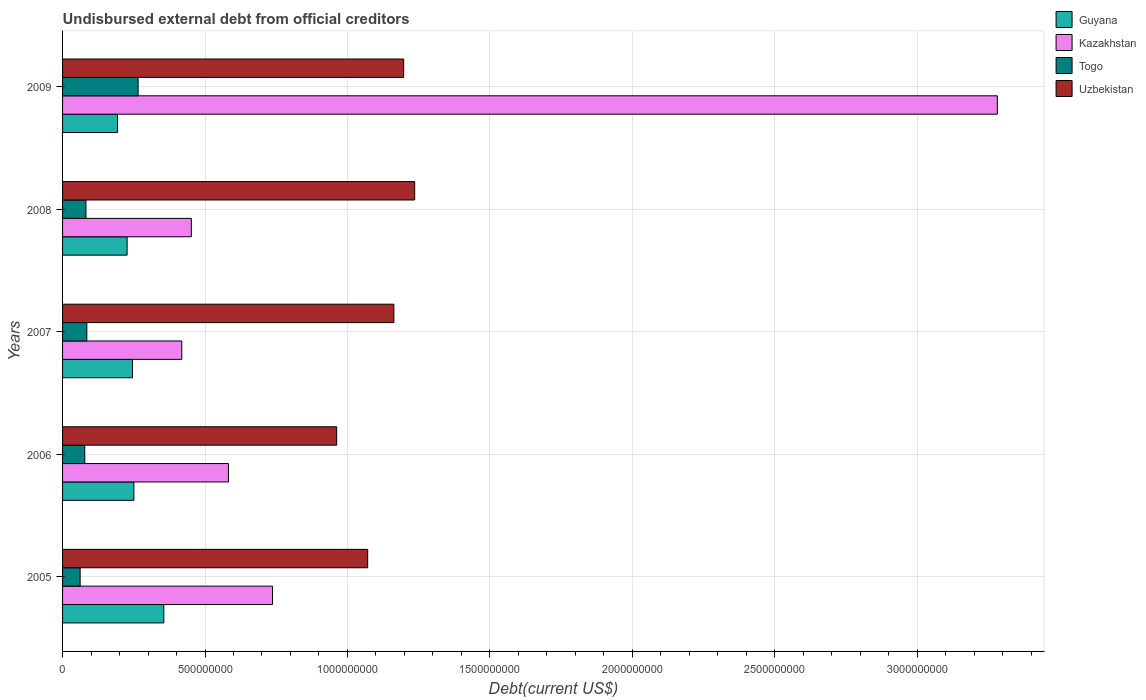How many groups of bars are there?
Provide a short and direct response. 5. Are the number of bars on each tick of the Y-axis equal?
Make the answer very short. Yes. How many bars are there on the 4th tick from the bottom?
Your answer should be compact. 4. What is the label of the 1st group of bars from the top?
Provide a succinct answer. 2009. What is the total debt in Togo in 2009?
Provide a succinct answer. 2.65e+08. Across all years, what is the maximum total debt in Togo?
Keep it short and to the point. 2.65e+08. Across all years, what is the minimum total debt in Guyana?
Make the answer very short. 1.93e+08. In which year was the total debt in Guyana maximum?
Your response must be concise. 2005. What is the total total debt in Guyana in the graph?
Give a very brief answer. 1.27e+09. What is the difference between the total debt in Guyana in 2006 and that in 2009?
Your response must be concise. 5.77e+07. What is the difference between the total debt in Togo in 2006 and the total debt in Guyana in 2008?
Give a very brief answer. -1.49e+08. What is the average total debt in Kazakhstan per year?
Offer a very short reply. 1.09e+09. In the year 2007, what is the difference between the total debt in Guyana and total debt in Togo?
Keep it short and to the point. 1.60e+08. In how many years, is the total debt in Guyana greater than 2900000000 US$?
Provide a succinct answer. 0. What is the ratio of the total debt in Togo in 2007 to that in 2008?
Offer a terse response. 1.04. Is the difference between the total debt in Guyana in 2008 and 2009 greater than the difference between the total debt in Togo in 2008 and 2009?
Your answer should be very brief. Yes. What is the difference between the highest and the second highest total debt in Togo?
Offer a very short reply. 1.80e+08. What is the difference between the highest and the lowest total debt in Togo?
Ensure brevity in your answer.  2.04e+08. In how many years, is the total debt in Uzbekistan greater than the average total debt in Uzbekistan taken over all years?
Provide a short and direct response. 3. Is it the case that in every year, the sum of the total debt in Kazakhstan and total debt in Guyana is greater than the sum of total debt in Uzbekistan and total debt in Togo?
Ensure brevity in your answer.  Yes. What does the 4th bar from the top in 2009 represents?
Ensure brevity in your answer.  Guyana. What does the 3rd bar from the bottom in 2006 represents?
Your response must be concise. Togo. Is it the case that in every year, the sum of the total debt in Kazakhstan and total debt in Uzbekistan is greater than the total debt in Guyana?
Your answer should be compact. Yes. How many bars are there?
Offer a terse response. 20. Does the graph contain grids?
Keep it short and to the point. Yes. How many legend labels are there?
Offer a terse response. 4. What is the title of the graph?
Your answer should be compact. Undisbursed external debt from official creditors. What is the label or title of the X-axis?
Offer a very short reply. Debt(current US$). What is the Debt(current US$) of Guyana in 2005?
Make the answer very short. 3.55e+08. What is the Debt(current US$) of Kazakhstan in 2005?
Offer a very short reply. 7.37e+08. What is the Debt(current US$) in Togo in 2005?
Offer a terse response. 6.17e+07. What is the Debt(current US$) in Uzbekistan in 2005?
Offer a very short reply. 1.07e+09. What is the Debt(current US$) in Guyana in 2006?
Your response must be concise. 2.50e+08. What is the Debt(current US$) in Kazakhstan in 2006?
Provide a short and direct response. 5.82e+08. What is the Debt(current US$) in Togo in 2006?
Your answer should be very brief. 7.79e+07. What is the Debt(current US$) in Uzbekistan in 2006?
Keep it short and to the point. 9.62e+08. What is the Debt(current US$) of Guyana in 2007?
Give a very brief answer. 2.45e+08. What is the Debt(current US$) of Kazakhstan in 2007?
Give a very brief answer. 4.18e+08. What is the Debt(current US$) in Togo in 2007?
Your answer should be very brief. 8.52e+07. What is the Debt(current US$) of Uzbekistan in 2007?
Give a very brief answer. 1.16e+09. What is the Debt(current US$) in Guyana in 2008?
Offer a terse response. 2.27e+08. What is the Debt(current US$) in Kazakhstan in 2008?
Provide a succinct answer. 4.52e+08. What is the Debt(current US$) of Togo in 2008?
Make the answer very short. 8.21e+07. What is the Debt(current US$) of Uzbekistan in 2008?
Provide a succinct answer. 1.24e+09. What is the Debt(current US$) of Guyana in 2009?
Give a very brief answer. 1.93e+08. What is the Debt(current US$) of Kazakhstan in 2009?
Provide a short and direct response. 3.28e+09. What is the Debt(current US$) in Togo in 2009?
Your answer should be compact. 2.65e+08. What is the Debt(current US$) in Uzbekistan in 2009?
Your answer should be very brief. 1.20e+09. Across all years, what is the maximum Debt(current US$) in Guyana?
Offer a very short reply. 3.55e+08. Across all years, what is the maximum Debt(current US$) of Kazakhstan?
Give a very brief answer. 3.28e+09. Across all years, what is the maximum Debt(current US$) of Togo?
Give a very brief answer. 2.65e+08. Across all years, what is the maximum Debt(current US$) of Uzbekistan?
Provide a succinct answer. 1.24e+09. Across all years, what is the minimum Debt(current US$) of Guyana?
Your answer should be very brief. 1.93e+08. Across all years, what is the minimum Debt(current US$) in Kazakhstan?
Your response must be concise. 4.18e+08. Across all years, what is the minimum Debt(current US$) of Togo?
Your answer should be compact. 6.17e+07. Across all years, what is the minimum Debt(current US$) of Uzbekistan?
Offer a terse response. 9.62e+08. What is the total Debt(current US$) of Guyana in the graph?
Offer a terse response. 1.27e+09. What is the total Debt(current US$) of Kazakhstan in the graph?
Provide a short and direct response. 5.47e+09. What is the total Debt(current US$) of Togo in the graph?
Offer a very short reply. 5.72e+08. What is the total Debt(current US$) of Uzbekistan in the graph?
Provide a short and direct response. 5.63e+09. What is the difference between the Debt(current US$) in Guyana in 2005 and that in 2006?
Your answer should be very brief. 1.05e+08. What is the difference between the Debt(current US$) in Kazakhstan in 2005 and that in 2006?
Your answer should be very brief. 1.55e+08. What is the difference between the Debt(current US$) of Togo in 2005 and that in 2006?
Ensure brevity in your answer.  -1.62e+07. What is the difference between the Debt(current US$) of Uzbekistan in 2005 and that in 2006?
Provide a succinct answer. 1.09e+08. What is the difference between the Debt(current US$) of Guyana in 2005 and that in 2007?
Ensure brevity in your answer.  1.10e+08. What is the difference between the Debt(current US$) in Kazakhstan in 2005 and that in 2007?
Your answer should be compact. 3.19e+08. What is the difference between the Debt(current US$) in Togo in 2005 and that in 2007?
Your response must be concise. -2.36e+07. What is the difference between the Debt(current US$) of Uzbekistan in 2005 and that in 2007?
Keep it short and to the point. -9.20e+07. What is the difference between the Debt(current US$) in Guyana in 2005 and that in 2008?
Ensure brevity in your answer.  1.29e+08. What is the difference between the Debt(current US$) of Kazakhstan in 2005 and that in 2008?
Make the answer very short. 2.85e+08. What is the difference between the Debt(current US$) of Togo in 2005 and that in 2008?
Your response must be concise. -2.05e+07. What is the difference between the Debt(current US$) of Uzbekistan in 2005 and that in 2008?
Provide a short and direct response. -1.65e+08. What is the difference between the Debt(current US$) in Guyana in 2005 and that in 2009?
Provide a short and direct response. 1.63e+08. What is the difference between the Debt(current US$) in Kazakhstan in 2005 and that in 2009?
Provide a succinct answer. -2.54e+09. What is the difference between the Debt(current US$) of Togo in 2005 and that in 2009?
Provide a succinct answer. -2.04e+08. What is the difference between the Debt(current US$) in Uzbekistan in 2005 and that in 2009?
Offer a terse response. -1.26e+08. What is the difference between the Debt(current US$) of Guyana in 2006 and that in 2007?
Provide a short and direct response. 5.15e+06. What is the difference between the Debt(current US$) of Kazakhstan in 2006 and that in 2007?
Your response must be concise. 1.64e+08. What is the difference between the Debt(current US$) of Togo in 2006 and that in 2007?
Provide a short and direct response. -7.33e+06. What is the difference between the Debt(current US$) of Uzbekistan in 2006 and that in 2007?
Ensure brevity in your answer.  -2.01e+08. What is the difference between the Debt(current US$) in Guyana in 2006 and that in 2008?
Your response must be concise. 2.38e+07. What is the difference between the Debt(current US$) of Kazakhstan in 2006 and that in 2008?
Your response must be concise. 1.30e+08. What is the difference between the Debt(current US$) in Togo in 2006 and that in 2008?
Keep it short and to the point. -4.21e+06. What is the difference between the Debt(current US$) of Uzbekistan in 2006 and that in 2008?
Provide a succinct answer. -2.74e+08. What is the difference between the Debt(current US$) of Guyana in 2006 and that in 2009?
Keep it short and to the point. 5.77e+07. What is the difference between the Debt(current US$) in Kazakhstan in 2006 and that in 2009?
Make the answer very short. -2.70e+09. What is the difference between the Debt(current US$) in Togo in 2006 and that in 2009?
Offer a very short reply. -1.87e+08. What is the difference between the Debt(current US$) in Uzbekistan in 2006 and that in 2009?
Offer a terse response. -2.35e+08. What is the difference between the Debt(current US$) of Guyana in 2007 and that in 2008?
Give a very brief answer. 1.87e+07. What is the difference between the Debt(current US$) of Kazakhstan in 2007 and that in 2008?
Your answer should be compact. -3.35e+07. What is the difference between the Debt(current US$) of Togo in 2007 and that in 2008?
Your answer should be very brief. 3.12e+06. What is the difference between the Debt(current US$) of Uzbekistan in 2007 and that in 2008?
Offer a terse response. -7.30e+07. What is the difference between the Debt(current US$) in Guyana in 2007 and that in 2009?
Make the answer very short. 5.26e+07. What is the difference between the Debt(current US$) in Kazakhstan in 2007 and that in 2009?
Keep it short and to the point. -2.86e+09. What is the difference between the Debt(current US$) of Togo in 2007 and that in 2009?
Offer a very short reply. -1.80e+08. What is the difference between the Debt(current US$) in Uzbekistan in 2007 and that in 2009?
Offer a terse response. -3.43e+07. What is the difference between the Debt(current US$) of Guyana in 2008 and that in 2009?
Ensure brevity in your answer.  3.39e+07. What is the difference between the Debt(current US$) in Kazakhstan in 2008 and that in 2009?
Offer a very short reply. -2.83e+09. What is the difference between the Debt(current US$) in Togo in 2008 and that in 2009?
Provide a short and direct response. -1.83e+08. What is the difference between the Debt(current US$) in Uzbekistan in 2008 and that in 2009?
Ensure brevity in your answer.  3.87e+07. What is the difference between the Debt(current US$) of Guyana in 2005 and the Debt(current US$) of Kazakhstan in 2006?
Provide a short and direct response. -2.27e+08. What is the difference between the Debt(current US$) of Guyana in 2005 and the Debt(current US$) of Togo in 2006?
Your answer should be compact. 2.77e+08. What is the difference between the Debt(current US$) of Guyana in 2005 and the Debt(current US$) of Uzbekistan in 2006?
Your answer should be compact. -6.07e+08. What is the difference between the Debt(current US$) in Kazakhstan in 2005 and the Debt(current US$) in Togo in 2006?
Your answer should be compact. 6.59e+08. What is the difference between the Debt(current US$) of Kazakhstan in 2005 and the Debt(current US$) of Uzbekistan in 2006?
Offer a very short reply. -2.25e+08. What is the difference between the Debt(current US$) of Togo in 2005 and the Debt(current US$) of Uzbekistan in 2006?
Offer a very short reply. -9.00e+08. What is the difference between the Debt(current US$) of Guyana in 2005 and the Debt(current US$) of Kazakhstan in 2007?
Provide a short and direct response. -6.31e+07. What is the difference between the Debt(current US$) in Guyana in 2005 and the Debt(current US$) in Togo in 2007?
Provide a succinct answer. 2.70e+08. What is the difference between the Debt(current US$) of Guyana in 2005 and the Debt(current US$) of Uzbekistan in 2007?
Provide a succinct answer. -8.08e+08. What is the difference between the Debt(current US$) of Kazakhstan in 2005 and the Debt(current US$) of Togo in 2007?
Provide a succinct answer. 6.52e+08. What is the difference between the Debt(current US$) of Kazakhstan in 2005 and the Debt(current US$) of Uzbekistan in 2007?
Provide a succinct answer. -4.26e+08. What is the difference between the Debt(current US$) of Togo in 2005 and the Debt(current US$) of Uzbekistan in 2007?
Your answer should be compact. -1.10e+09. What is the difference between the Debt(current US$) in Guyana in 2005 and the Debt(current US$) in Kazakhstan in 2008?
Make the answer very short. -9.66e+07. What is the difference between the Debt(current US$) in Guyana in 2005 and the Debt(current US$) in Togo in 2008?
Provide a short and direct response. 2.73e+08. What is the difference between the Debt(current US$) in Guyana in 2005 and the Debt(current US$) in Uzbekistan in 2008?
Your response must be concise. -8.81e+08. What is the difference between the Debt(current US$) of Kazakhstan in 2005 and the Debt(current US$) of Togo in 2008?
Give a very brief answer. 6.55e+08. What is the difference between the Debt(current US$) of Kazakhstan in 2005 and the Debt(current US$) of Uzbekistan in 2008?
Give a very brief answer. -4.99e+08. What is the difference between the Debt(current US$) of Togo in 2005 and the Debt(current US$) of Uzbekistan in 2008?
Provide a succinct answer. -1.17e+09. What is the difference between the Debt(current US$) of Guyana in 2005 and the Debt(current US$) of Kazakhstan in 2009?
Offer a very short reply. -2.93e+09. What is the difference between the Debt(current US$) of Guyana in 2005 and the Debt(current US$) of Togo in 2009?
Give a very brief answer. 9.02e+07. What is the difference between the Debt(current US$) in Guyana in 2005 and the Debt(current US$) in Uzbekistan in 2009?
Keep it short and to the point. -8.42e+08. What is the difference between the Debt(current US$) of Kazakhstan in 2005 and the Debt(current US$) of Togo in 2009?
Keep it short and to the point. 4.72e+08. What is the difference between the Debt(current US$) of Kazakhstan in 2005 and the Debt(current US$) of Uzbekistan in 2009?
Ensure brevity in your answer.  -4.60e+08. What is the difference between the Debt(current US$) of Togo in 2005 and the Debt(current US$) of Uzbekistan in 2009?
Your answer should be very brief. -1.14e+09. What is the difference between the Debt(current US$) in Guyana in 2006 and the Debt(current US$) in Kazakhstan in 2007?
Keep it short and to the point. -1.68e+08. What is the difference between the Debt(current US$) in Guyana in 2006 and the Debt(current US$) in Togo in 2007?
Make the answer very short. 1.65e+08. What is the difference between the Debt(current US$) of Guyana in 2006 and the Debt(current US$) of Uzbekistan in 2007?
Make the answer very short. -9.13e+08. What is the difference between the Debt(current US$) in Kazakhstan in 2006 and the Debt(current US$) in Togo in 2007?
Provide a short and direct response. 4.97e+08. What is the difference between the Debt(current US$) of Kazakhstan in 2006 and the Debt(current US$) of Uzbekistan in 2007?
Your answer should be very brief. -5.81e+08. What is the difference between the Debt(current US$) of Togo in 2006 and the Debt(current US$) of Uzbekistan in 2007?
Ensure brevity in your answer.  -1.09e+09. What is the difference between the Debt(current US$) of Guyana in 2006 and the Debt(current US$) of Kazakhstan in 2008?
Give a very brief answer. -2.02e+08. What is the difference between the Debt(current US$) of Guyana in 2006 and the Debt(current US$) of Togo in 2008?
Provide a succinct answer. 1.68e+08. What is the difference between the Debt(current US$) of Guyana in 2006 and the Debt(current US$) of Uzbekistan in 2008?
Your answer should be very brief. -9.86e+08. What is the difference between the Debt(current US$) of Kazakhstan in 2006 and the Debt(current US$) of Togo in 2008?
Offer a very short reply. 5.00e+08. What is the difference between the Debt(current US$) of Kazakhstan in 2006 and the Debt(current US$) of Uzbekistan in 2008?
Offer a terse response. -6.54e+08. What is the difference between the Debt(current US$) of Togo in 2006 and the Debt(current US$) of Uzbekistan in 2008?
Offer a terse response. -1.16e+09. What is the difference between the Debt(current US$) in Guyana in 2006 and the Debt(current US$) in Kazakhstan in 2009?
Your answer should be compact. -3.03e+09. What is the difference between the Debt(current US$) in Guyana in 2006 and the Debt(current US$) in Togo in 2009?
Offer a terse response. -1.48e+07. What is the difference between the Debt(current US$) in Guyana in 2006 and the Debt(current US$) in Uzbekistan in 2009?
Provide a succinct answer. -9.47e+08. What is the difference between the Debt(current US$) of Kazakhstan in 2006 and the Debt(current US$) of Togo in 2009?
Offer a very short reply. 3.17e+08. What is the difference between the Debt(current US$) of Kazakhstan in 2006 and the Debt(current US$) of Uzbekistan in 2009?
Ensure brevity in your answer.  -6.15e+08. What is the difference between the Debt(current US$) in Togo in 2006 and the Debt(current US$) in Uzbekistan in 2009?
Offer a very short reply. -1.12e+09. What is the difference between the Debt(current US$) in Guyana in 2007 and the Debt(current US$) in Kazakhstan in 2008?
Your answer should be compact. -2.07e+08. What is the difference between the Debt(current US$) of Guyana in 2007 and the Debt(current US$) of Togo in 2008?
Your response must be concise. 1.63e+08. What is the difference between the Debt(current US$) of Guyana in 2007 and the Debt(current US$) of Uzbekistan in 2008?
Your answer should be compact. -9.91e+08. What is the difference between the Debt(current US$) in Kazakhstan in 2007 and the Debt(current US$) in Togo in 2008?
Offer a terse response. 3.36e+08. What is the difference between the Debt(current US$) in Kazakhstan in 2007 and the Debt(current US$) in Uzbekistan in 2008?
Offer a terse response. -8.18e+08. What is the difference between the Debt(current US$) of Togo in 2007 and the Debt(current US$) of Uzbekistan in 2008?
Your answer should be very brief. -1.15e+09. What is the difference between the Debt(current US$) of Guyana in 2007 and the Debt(current US$) of Kazakhstan in 2009?
Give a very brief answer. -3.04e+09. What is the difference between the Debt(current US$) in Guyana in 2007 and the Debt(current US$) in Togo in 2009?
Provide a succinct answer. -2.00e+07. What is the difference between the Debt(current US$) of Guyana in 2007 and the Debt(current US$) of Uzbekistan in 2009?
Your answer should be compact. -9.52e+08. What is the difference between the Debt(current US$) in Kazakhstan in 2007 and the Debt(current US$) in Togo in 2009?
Your response must be concise. 1.53e+08. What is the difference between the Debt(current US$) of Kazakhstan in 2007 and the Debt(current US$) of Uzbekistan in 2009?
Keep it short and to the point. -7.79e+08. What is the difference between the Debt(current US$) of Togo in 2007 and the Debt(current US$) of Uzbekistan in 2009?
Keep it short and to the point. -1.11e+09. What is the difference between the Debt(current US$) in Guyana in 2008 and the Debt(current US$) in Kazakhstan in 2009?
Offer a terse response. -3.05e+09. What is the difference between the Debt(current US$) of Guyana in 2008 and the Debt(current US$) of Togo in 2009?
Your response must be concise. -3.86e+07. What is the difference between the Debt(current US$) of Guyana in 2008 and the Debt(current US$) of Uzbekistan in 2009?
Offer a terse response. -9.71e+08. What is the difference between the Debt(current US$) in Kazakhstan in 2008 and the Debt(current US$) in Togo in 2009?
Your answer should be very brief. 1.87e+08. What is the difference between the Debt(current US$) in Kazakhstan in 2008 and the Debt(current US$) in Uzbekistan in 2009?
Make the answer very short. -7.45e+08. What is the difference between the Debt(current US$) of Togo in 2008 and the Debt(current US$) of Uzbekistan in 2009?
Make the answer very short. -1.12e+09. What is the average Debt(current US$) of Guyana per year?
Offer a terse response. 2.54e+08. What is the average Debt(current US$) of Kazakhstan per year?
Give a very brief answer. 1.09e+09. What is the average Debt(current US$) of Togo per year?
Offer a very short reply. 1.14e+08. What is the average Debt(current US$) of Uzbekistan per year?
Provide a short and direct response. 1.13e+09. In the year 2005, what is the difference between the Debt(current US$) in Guyana and Debt(current US$) in Kazakhstan?
Make the answer very short. -3.82e+08. In the year 2005, what is the difference between the Debt(current US$) in Guyana and Debt(current US$) in Togo?
Your answer should be compact. 2.94e+08. In the year 2005, what is the difference between the Debt(current US$) of Guyana and Debt(current US$) of Uzbekistan?
Provide a succinct answer. -7.16e+08. In the year 2005, what is the difference between the Debt(current US$) of Kazakhstan and Debt(current US$) of Togo?
Make the answer very short. 6.75e+08. In the year 2005, what is the difference between the Debt(current US$) of Kazakhstan and Debt(current US$) of Uzbekistan?
Ensure brevity in your answer.  -3.34e+08. In the year 2005, what is the difference between the Debt(current US$) in Togo and Debt(current US$) in Uzbekistan?
Provide a short and direct response. -1.01e+09. In the year 2006, what is the difference between the Debt(current US$) of Guyana and Debt(current US$) of Kazakhstan?
Your response must be concise. -3.32e+08. In the year 2006, what is the difference between the Debt(current US$) in Guyana and Debt(current US$) in Togo?
Keep it short and to the point. 1.72e+08. In the year 2006, what is the difference between the Debt(current US$) of Guyana and Debt(current US$) of Uzbekistan?
Your answer should be very brief. -7.12e+08. In the year 2006, what is the difference between the Debt(current US$) in Kazakhstan and Debt(current US$) in Togo?
Offer a very short reply. 5.04e+08. In the year 2006, what is the difference between the Debt(current US$) of Kazakhstan and Debt(current US$) of Uzbekistan?
Keep it short and to the point. -3.80e+08. In the year 2006, what is the difference between the Debt(current US$) of Togo and Debt(current US$) of Uzbekistan?
Provide a succinct answer. -8.84e+08. In the year 2007, what is the difference between the Debt(current US$) of Guyana and Debt(current US$) of Kazakhstan?
Ensure brevity in your answer.  -1.73e+08. In the year 2007, what is the difference between the Debt(current US$) of Guyana and Debt(current US$) of Togo?
Your answer should be very brief. 1.60e+08. In the year 2007, what is the difference between the Debt(current US$) of Guyana and Debt(current US$) of Uzbekistan?
Keep it short and to the point. -9.18e+08. In the year 2007, what is the difference between the Debt(current US$) of Kazakhstan and Debt(current US$) of Togo?
Your answer should be compact. 3.33e+08. In the year 2007, what is the difference between the Debt(current US$) of Kazakhstan and Debt(current US$) of Uzbekistan?
Your response must be concise. -7.45e+08. In the year 2007, what is the difference between the Debt(current US$) of Togo and Debt(current US$) of Uzbekistan?
Ensure brevity in your answer.  -1.08e+09. In the year 2008, what is the difference between the Debt(current US$) in Guyana and Debt(current US$) in Kazakhstan?
Keep it short and to the point. -2.25e+08. In the year 2008, what is the difference between the Debt(current US$) in Guyana and Debt(current US$) in Togo?
Offer a very short reply. 1.44e+08. In the year 2008, what is the difference between the Debt(current US$) in Guyana and Debt(current US$) in Uzbekistan?
Offer a very short reply. -1.01e+09. In the year 2008, what is the difference between the Debt(current US$) in Kazakhstan and Debt(current US$) in Togo?
Offer a terse response. 3.70e+08. In the year 2008, what is the difference between the Debt(current US$) of Kazakhstan and Debt(current US$) of Uzbekistan?
Keep it short and to the point. -7.84e+08. In the year 2008, what is the difference between the Debt(current US$) in Togo and Debt(current US$) in Uzbekistan?
Keep it short and to the point. -1.15e+09. In the year 2009, what is the difference between the Debt(current US$) in Guyana and Debt(current US$) in Kazakhstan?
Ensure brevity in your answer.  -3.09e+09. In the year 2009, what is the difference between the Debt(current US$) in Guyana and Debt(current US$) in Togo?
Keep it short and to the point. -7.25e+07. In the year 2009, what is the difference between the Debt(current US$) of Guyana and Debt(current US$) of Uzbekistan?
Keep it short and to the point. -1.00e+09. In the year 2009, what is the difference between the Debt(current US$) in Kazakhstan and Debt(current US$) in Togo?
Give a very brief answer. 3.02e+09. In the year 2009, what is the difference between the Debt(current US$) in Kazakhstan and Debt(current US$) in Uzbekistan?
Keep it short and to the point. 2.08e+09. In the year 2009, what is the difference between the Debt(current US$) in Togo and Debt(current US$) in Uzbekistan?
Give a very brief answer. -9.32e+08. What is the ratio of the Debt(current US$) of Guyana in 2005 to that in 2006?
Your answer should be compact. 1.42. What is the ratio of the Debt(current US$) in Kazakhstan in 2005 to that in 2006?
Your answer should be very brief. 1.27. What is the ratio of the Debt(current US$) in Togo in 2005 to that in 2006?
Offer a terse response. 0.79. What is the ratio of the Debt(current US$) in Uzbekistan in 2005 to that in 2006?
Provide a succinct answer. 1.11. What is the ratio of the Debt(current US$) in Guyana in 2005 to that in 2007?
Your answer should be compact. 1.45. What is the ratio of the Debt(current US$) in Kazakhstan in 2005 to that in 2007?
Provide a succinct answer. 1.76. What is the ratio of the Debt(current US$) of Togo in 2005 to that in 2007?
Keep it short and to the point. 0.72. What is the ratio of the Debt(current US$) of Uzbekistan in 2005 to that in 2007?
Keep it short and to the point. 0.92. What is the ratio of the Debt(current US$) of Guyana in 2005 to that in 2008?
Your response must be concise. 1.57. What is the ratio of the Debt(current US$) of Kazakhstan in 2005 to that in 2008?
Provide a succinct answer. 1.63. What is the ratio of the Debt(current US$) in Togo in 2005 to that in 2008?
Make the answer very short. 0.75. What is the ratio of the Debt(current US$) in Uzbekistan in 2005 to that in 2008?
Offer a very short reply. 0.87. What is the ratio of the Debt(current US$) in Guyana in 2005 to that in 2009?
Keep it short and to the point. 1.84. What is the ratio of the Debt(current US$) in Kazakhstan in 2005 to that in 2009?
Make the answer very short. 0.22. What is the ratio of the Debt(current US$) of Togo in 2005 to that in 2009?
Your response must be concise. 0.23. What is the ratio of the Debt(current US$) of Uzbekistan in 2005 to that in 2009?
Ensure brevity in your answer.  0.89. What is the ratio of the Debt(current US$) of Kazakhstan in 2006 to that in 2007?
Keep it short and to the point. 1.39. What is the ratio of the Debt(current US$) in Togo in 2006 to that in 2007?
Make the answer very short. 0.91. What is the ratio of the Debt(current US$) of Uzbekistan in 2006 to that in 2007?
Offer a very short reply. 0.83. What is the ratio of the Debt(current US$) of Guyana in 2006 to that in 2008?
Your answer should be very brief. 1.11. What is the ratio of the Debt(current US$) in Kazakhstan in 2006 to that in 2008?
Provide a succinct answer. 1.29. What is the ratio of the Debt(current US$) in Togo in 2006 to that in 2008?
Make the answer very short. 0.95. What is the ratio of the Debt(current US$) of Uzbekistan in 2006 to that in 2008?
Ensure brevity in your answer.  0.78. What is the ratio of the Debt(current US$) in Guyana in 2006 to that in 2009?
Offer a very short reply. 1.3. What is the ratio of the Debt(current US$) in Kazakhstan in 2006 to that in 2009?
Give a very brief answer. 0.18. What is the ratio of the Debt(current US$) in Togo in 2006 to that in 2009?
Provide a succinct answer. 0.29. What is the ratio of the Debt(current US$) in Uzbekistan in 2006 to that in 2009?
Provide a succinct answer. 0.8. What is the ratio of the Debt(current US$) of Guyana in 2007 to that in 2008?
Ensure brevity in your answer.  1.08. What is the ratio of the Debt(current US$) in Kazakhstan in 2007 to that in 2008?
Offer a terse response. 0.93. What is the ratio of the Debt(current US$) in Togo in 2007 to that in 2008?
Your answer should be compact. 1.04. What is the ratio of the Debt(current US$) of Uzbekistan in 2007 to that in 2008?
Provide a short and direct response. 0.94. What is the ratio of the Debt(current US$) of Guyana in 2007 to that in 2009?
Give a very brief answer. 1.27. What is the ratio of the Debt(current US$) in Kazakhstan in 2007 to that in 2009?
Offer a terse response. 0.13. What is the ratio of the Debt(current US$) of Togo in 2007 to that in 2009?
Provide a succinct answer. 0.32. What is the ratio of the Debt(current US$) in Uzbekistan in 2007 to that in 2009?
Your answer should be very brief. 0.97. What is the ratio of the Debt(current US$) of Guyana in 2008 to that in 2009?
Offer a terse response. 1.18. What is the ratio of the Debt(current US$) in Kazakhstan in 2008 to that in 2009?
Provide a succinct answer. 0.14. What is the ratio of the Debt(current US$) in Togo in 2008 to that in 2009?
Your answer should be compact. 0.31. What is the ratio of the Debt(current US$) of Uzbekistan in 2008 to that in 2009?
Offer a very short reply. 1.03. What is the difference between the highest and the second highest Debt(current US$) of Guyana?
Give a very brief answer. 1.05e+08. What is the difference between the highest and the second highest Debt(current US$) of Kazakhstan?
Offer a very short reply. 2.54e+09. What is the difference between the highest and the second highest Debt(current US$) in Togo?
Your answer should be compact. 1.80e+08. What is the difference between the highest and the second highest Debt(current US$) in Uzbekistan?
Your answer should be compact. 3.87e+07. What is the difference between the highest and the lowest Debt(current US$) in Guyana?
Make the answer very short. 1.63e+08. What is the difference between the highest and the lowest Debt(current US$) of Kazakhstan?
Ensure brevity in your answer.  2.86e+09. What is the difference between the highest and the lowest Debt(current US$) in Togo?
Keep it short and to the point. 2.04e+08. What is the difference between the highest and the lowest Debt(current US$) in Uzbekistan?
Offer a very short reply. 2.74e+08. 